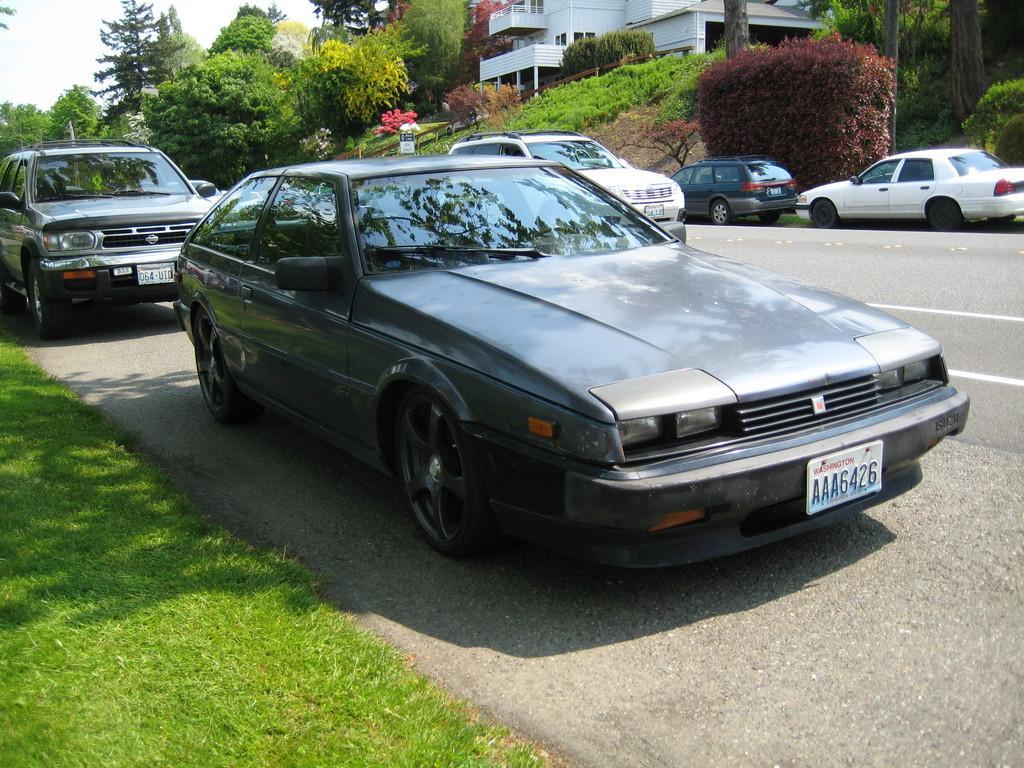Could you give a brief overview of what you see in this image? In this image, in the middle there are cars, trees, plants, building, grass, road, sky. 